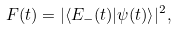<formula> <loc_0><loc_0><loc_500><loc_500>F ( t ) = | \langle E _ { - } ( t ) | \psi ( t ) \rangle | ^ { 2 } ,</formula> 